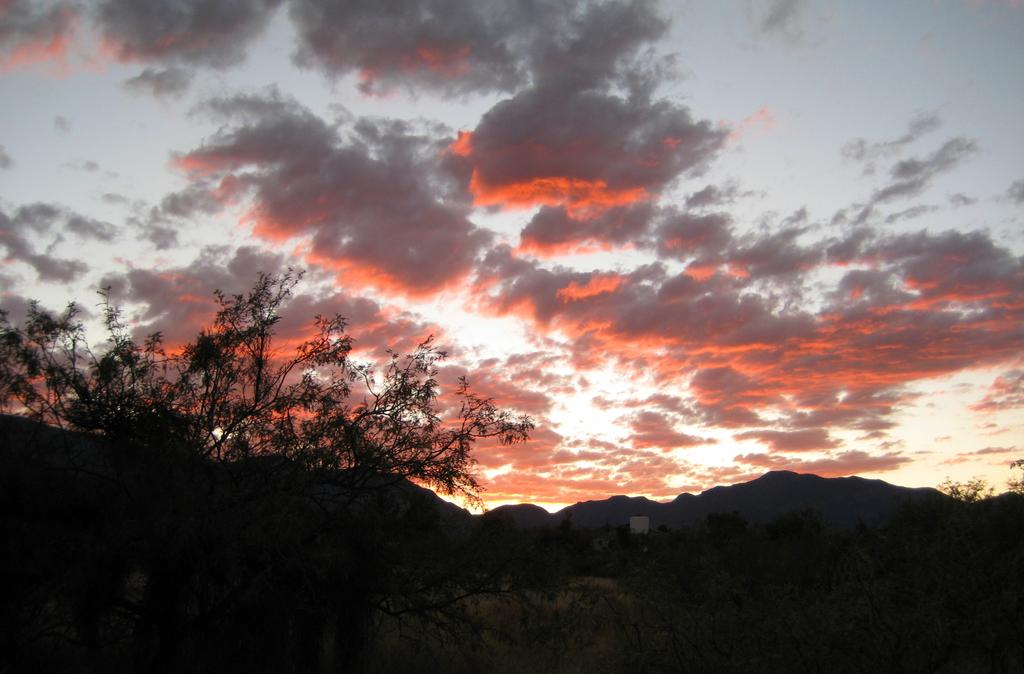What type of vegetation can be seen in the foreground of the image? There are trees in the foreground of the image. What type of natural feature is visible in the background of the image? There are mountains in the background of the image. What else can be seen in the background of the image? The sky and clouds are visible in the background of the image. How many apples are being coached by the beginner in the image? There are no apples, coaches, or beginners present in the image. 